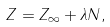Convert formula to latex. <formula><loc_0><loc_0><loc_500><loc_500>Z = Z _ { \infty } + \lambda N ,</formula> 